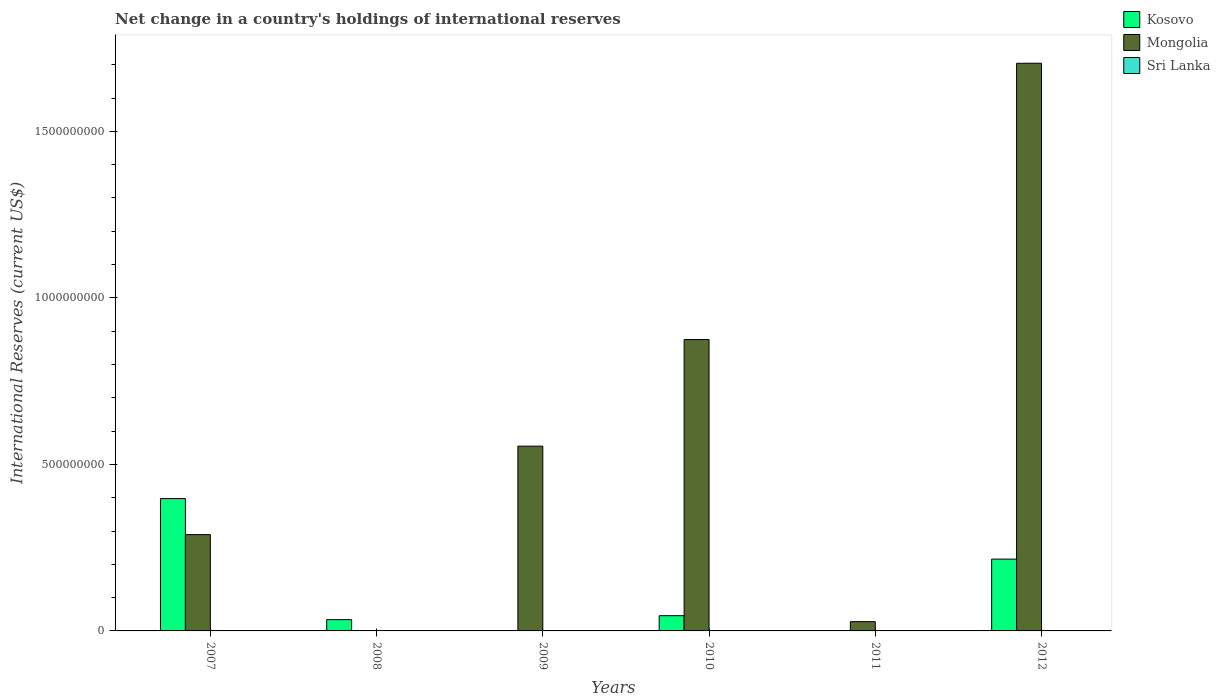How many bars are there on the 2nd tick from the left?
Your response must be concise. 1. What is the label of the 1st group of bars from the left?
Keep it short and to the point. 2007. In how many cases, is the number of bars for a given year not equal to the number of legend labels?
Give a very brief answer. 6. What is the international reserves in Kosovo in 2010?
Offer a very short reply. 4.57e+07. Across all years, what is the maximum international reserves in Mongolia?
Offer a very short reply. 1.70e+09. In which year was the international reserves in Kosovo maximum?
Ensure brevity in your answer.  2007. What is the total international reserves in Mongolia in the graph?
Your response must be concise. 3.45e+09. What is the difference between the international reserves in Kosovo in 2008 and that in 2012?
Provide a succinct answer. -1.82e+08. What is the difference between the international reserves in Kosovo in 2010 and the international reserves in Mongolia in 2009?
Give a very brief answer. -5.09e+08. In the year 2007, what is the difference between the international reserves in Mongolia and international reserves in Kosovo?
Ensure brevity in your answer.  -1.08e+08. What is the ratio of the international reserves in Mongolia in 2009 to that in 2012?
Provide a succinct answer. 0.33. Is the international reserves in Mongolia in 2009 less than that in 2012?
Offer a terse response. Yes. What is the difference between the highest and the second highest international reserves in Mongolia?
Keep it short and to the point. 8.30e+08. What is the difference between the highest and the lowest international reserves in Mongolia?
Give a very brief answer. 1.70e+09. In how many years, is the international reserves in Kosovo greater than the average international reserves in Kosovo taken over all years?
Provide a short and direct response. 2. Is the sum of the international reserves in Mongolia in 2007 and 2010 greater than the maximum international reserves in Sri Lanka across all years?
Ensure brevity in your answer.  Yes. Is it the case that in every year, the sum of the international reserves in Mongolia and international reserves in Sri Lanka is greater than the international reserves in Kosovo?
Provide a short and direct response. No. Are all the bars in the graph horizontal?
Your answer should be very brief. No. Are the values on the major ticks of Y-axis written in scientific E-notation?
Your answer should be very brief. No. How many legend labels are there?
Make the answer very short. 3. How are the legend labels stacked?
Give a very brief answer. Vertical. What is the title of the graph?
Give a very brief answer. Net change in a country's holdings of international reserves. Does "Greece" appear as one of the legend labels in the graph?
Provide a succinct answer. No. What is the label or title of the X-axis?
Ensure brevity in your answer.  Years. What is the label or title of the Y-axis?
Your answer should be compact. International Reserves (current US$). What is the International Reserves (current US$) of Kosovo in 2007?
Offer a terse response. 3.97e+08. What is the International Reserves (current US$) of Mongolia in 2007?
Offer a very short reply. 2.89e+08. What is the International Reserves (current US$) of Sri Lanka in 2007?
Ensure brevity in your answer.  0. What is the International Reserves (current US$) in Kosovo in 2008?
Offer a very short reply. 3.38e+07. What is the International Reserves (current US$) in Mongolia in 2008?
Offer a terse response. 0. What is the International Reserves (current US$) in Kosovo in 2009?
Offer a very short reply. 0. What is the International Reserves (current US$) in Mongolia in 2009?
Ensure brevity in your answer.  5.55e+08. What is the International Reserves (current US$) of Sri Lanka in 2009?
Your answer should be compact. 0. What is the International Reserves (current US$) in Kosovo in 2010?
Offer a terse response. 4.57e+07. What is the International Reserves (current US$) in Mongolia in 2010?
Your answer should be compact. 8.75e+08. What is the International Reserves (current US$) of Sri Lanka in 2010?
Your response must be concise. 0. What is the International Reserves (current US$) of Kosovo in 2011?
Keep it short and to the point. 0. What is the International Reserves (current US$) of Mongolia in 2011?
Make the answer very short. 2.79e+07. What is the International Reserves (current US$) of Kosovo in 2012?
Your response must be concise. 2.16e+08. What is the International Reserves (current US$) in Mongolia in 2012?
Your answer should be compact. 1.70e+09. What is the International Reserves (current US$) in Sri Lanka in 2012?
Make the answer very short. 0. Across all years, what is the maximum International Reserves (current US$) in Kosovo?
Your answer should be compact. 3.97e+08. Across all years, what is the maximum International Reserves (current US$) in Mongolia?
Offer a very short reply. 1.70e+09. Across all years, what is the minimum International Reserves (current US$) of Kosovo?
Keep it short and to the point. 0. What is the total International Reserves (current US$) of Kosovo in the graph?
Make the answer very short. 6.92e+08. What is the total International Reserves (current US$) in Mongolia in the graph?
Offer a very short reply. 3.45e+09. What is the difference between the International Reserves (current US$) of Kosovo in 2007 and that in 2008?
Ensure brevity in your answer.  3.63e+08. What is the difference between the International Reserves (current US$) of Mongolia in 2007 and that in 2009?
Provide a succinct answer. -2.66e+08. What is the difference between the International Reserves (current US$) of Kosovo in 2007 and that in 2010?
Offer a very short reply. 3.52e+08. What is the difference between the International Reserves (current US$) in Mongolia in 2007 and that in 2010?
Offer a terse response. -5.86e+08. What is the difference between the International Reserves (current US$) of Mongolia in 2007 and that in 2011?
Offer a very short reply. 2.61e+08. What is the difference between the International Reserves (current US$) in Kosovo in 2007 and that in 2012?
Your answer should be very brief. 1.82e+08. What is the difference between the International Reserves (current US$) of Mongolia in 2007 and that in 2012?
Ensure brevity in your answer.  -1.42e+09. What is the difference between the International Reserves (current US$) of Kosovo in 2008 and that in 2010?
Provide a short and direct response. -1.19e+07. What is the difference between the International Reserves (current US$) in Kosovo in 2008 and that in 2012?
Offer a terse response. -1.82e+08. What is the difference between the International Reserves (current US$) of Mongolia in 2009 and that in 2010?
Give a very brief answer. -3.20e+08. What is the difference between the International Reserves (current US$) of Mongolia in 2009 and that in 2011?
Offer a terse response. 5.27e+08. What is the difference between the International Reserves (current US$) of Mongolia in 2009 and that in 2012?
Provide a succinct answer. -1.15e+09. What is the difference between the International Reserves (current US$) of Mongolia in 2010 and that in 2011?
Your response must be concise. 8.47e+08. What is the difference between the International Reserves (current US$) in Kosovo in 2010 and that in 2012?
Keep it short and to the point. -1.70e+08. What is the difference between the International Reserves (current US$) in Mongolia in 2010 and that in 2012?
Ensure brevity in your answer.  -8.30e+08. What is the difference between the International Reserves (current US$) of Mongolia in 2011 and that in 2012?
Provide a succinct answer. -1.68e+09. What is the difference between the International Reserves (current US$) of Kosovo in 2007 and the International Reserves (current US$) of Mongolia in 2009?
Ensure brevity in your answer.  -1.57e+08. What is the difference between the International Reserves (current US$) in Kosovo in 2007 and the International Reserves (current US$) in Mongolia in 2010?
Provide a short and direct response. -4.78e+08. What is the difference between the International Reserves (current US$) of Kosovo in 2007 and the International Reserves (current US$) of Mongolia in 2011?
Make the answer very short. 3.69e+08. What is the difference between the International Reserves (current US$) in Kosovo in 2007 and the International Reserves (current US$) in Mongolia in 2012?
Provide a succinct answer. -1.31e+09. What is the difference between the International Reserves (current US$) of Kosovo in 2008 and the International Reserves (current US$) of Mongolia in 2009?
Keep it short and to the point. -5.21e+08. What is the difference between the International Reserves (current US$) in Kosovo in 2008 and the International Reserves (current US$) in Mongolia in 2010?
Provide a short and direct response. -8.41e+08. What is the difference between the International Reserves (current US$) in Kosovo in 2008 and the International Reserves (current US$) in Mongolia in 2011?
Make the answer very short. 5.93e+06. What is the difference between the International Reserves (current US$) in Kosovo in 2008 and the International Reserves (current US$) in Mongolia in 2012?
Offer a very short reply. -1.67e+09. What is the difference between the International Reserves (current US$) in Kosovo in 2010 and the International Reserves (current US$) in Mongolia in 2011?
Your response must be concise. 1.78e+07. What is the difference between the International Reserves (current US$) in Kosovo in 2010 and the International Reserves (current US$) in Mongolia in 2012?
Make the answer very short. -1.66e+09. What is the average International Reserves (current US$) of Kosovo per year?
Offer a terse response. 1.15e+08. What is the average International Reserves (current US$) of Mongolia per year?
Offer a terse response. 5.75e+08. In the year 2007, what is the difference between the International Reserves (current US$) of Kosovo and International Reserves (current US$) of Mongolia?
Your answer should be compact. 1.08e+08. In the year 2010, what is the difference between the International Reserves (current US$) in Kosovo and International Reserves (current US$) in Mongolia?
Your response must be concise. -8.29e+08. In the year 2012, what is the difference between the International Reserves (current US$) of Kosovo and International Reserves (current US$) of Mongolia?
Your response must be concise. -1.49e+09. What is the ratio of the International Reserves (current US$) in Kosovo in 2007 to that in 2008?
Your response must be concise. 11.75. What is the ratio of the International Reserves (current US$) in Mongolia in 2007 to that in 2009?
Your answer should be compact. 0.52. What is the ratio of the International Reserves (current US$) of Kosovo in 2007 to that in 2010?
Your answer should be compact. 8.69. What is the ratio of the International Reserves (current US$) in Mongolia in 2007 to that in 2010?
Your answer should be very brief. 0.33. What is the ratio of the International Reserves (current US$) of Mongolia in 2007 to that in 2011?
Your answer should be very brief. 10.37. What is the ratio of the International Reserves (current US$) in Kosovo in 2007 to that in 2012?
Provide a succinct answer. 1.84. What is the ratio of the International Reserves (current US$) in Mongolia in 2007 to that in 2012?
Provide a short and direct response. 0.17. What is the ratio of the International Reserves (current US$) in Kosovo in 2008 to that in 2010?
Provide a short and direct response. 0.74. What is the ratio of the International Reserves (current US$) in Kosovo in 2008 to that in 2012?
Give a very brief answer. 0.16. What is the ratio of the International Reserves (current US$) in Mongolia in 2009 to that in 2010?
Your response must be concise. 0.63. What is the ratio of the International Reserves (current US$) of Mongolia in 2009 to that in 2011?
Keep it short and to the point. 19.89. What is the ratio of the International Reserves (current US$) of Mongolia in 2009 to that in 2012?
Make the answer very short. 0.33. What is the ratio of the International Reserves (current US$) in Mongolia in 2010 to that in 2011?
Make the answer very short. 31.36. What is the ratio of the International Reserves (current US$) in Kosovo in 2010 to that in 2012?
Your response must be concise. 0.21. What is the ratio of the International Reserves (current US$) in Mongolia in 2010 to that in 2012?
Give a very brief answer. 0.51. What is the ratio of the International Reserves (current US$) of Mongolia in 2011 to that in 2012?
Ensure brevity in your answer.  0.02. What is the difference between the highest and the second highest International Reserves (current US$) in Kosovo?
Your response must be concise. 1.82e+08. What is the difference between the highest and the second highest International Reserves (current US$) in Mongolia?
Provide a short and direct response. 8.30e+08. What is the difference between the highest and the lowest International Reserves (current US$) in Kosovo?
Give a very brief answer. 3.97e+08. What is the difference between the highest and the lowest International Reserves (current US$) of Mongolia?
Give a very brief answer. 1.70e+09. 